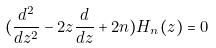<formula> <loc_0><loc_0><loc_500><loc_500>( \frac { d ^ { 2 } } { d z ^ { 2 } } - 2 z \frac { d } { d z } + 2 n ) H _ { n } ( z ) = 0</formula> 